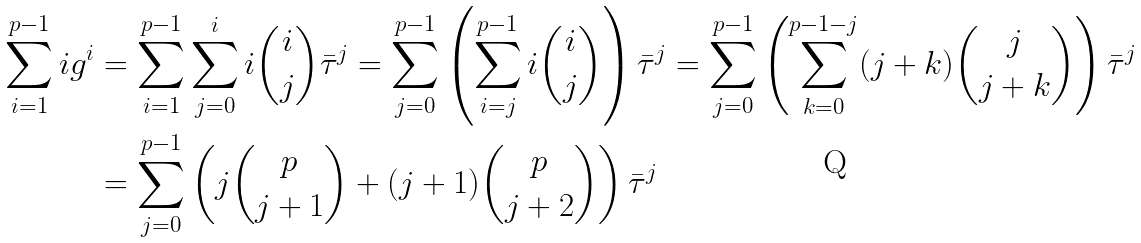<formula> <loc_0><loc_0><loc_500><loc_500>\sum _ { i = 1 } ^ { p - 1 } i g ^ { i } & = \sum _ { i = 1 } ^ { p - 1 } \sum _ { j = 0 } ^ { i } i \binom { i } { j } \bar { \tau } ^ { j } = \sum _ { j = 0 } ^ { p - 1 } \left ( \sum _ { i = j } ^ { p - 1 } i \binom { i } { j } \right ) \bar { \tau } ^ { j } = \sum _ { j = 0 } ^ { p - 1 } \left ( \sum _ { k = 0 } ^ { p - 1 - j } ( j + k ) \binom { j } { j + k } \right ) \bar { \tau } ^ { j } \\ & = \sum _ { j = 0 } ^ { p - 1 } \left ( j \binom { p } { j + 1 } + ( j + 1 ) \binom { p } { j + 2 } \right ) \bar { \tau } ^ { j }</formula> 